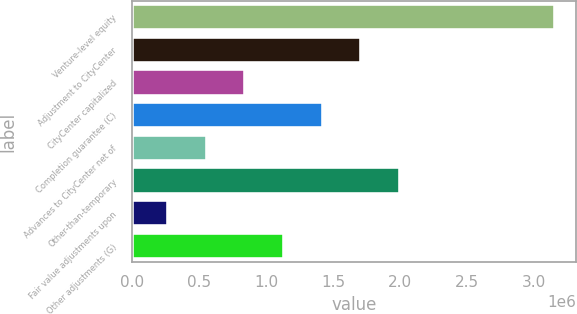Convert chart. <chart><loc_0><loc_0><loc_500><loc_500><bar_chart><fcel>Venture-level equity<fcel>Adjustment to CityCenter<fcel>CityCenter capitalized<fcel>Completion guarantee (C)<fcel>Advances to CityCenter net of<fcel>Other-than-temporary<fcel>Fair value adjustments upon<fcel>Other adjustments (G)<nl><fcel>3.15663e+06<fcel>1.71191e+06<fcel>845078<fcel>1.42297e+06<fcel>556134<fcel>2.00085e+06<fcel>267190<fcel>1.13402e+06<nl></chart> 